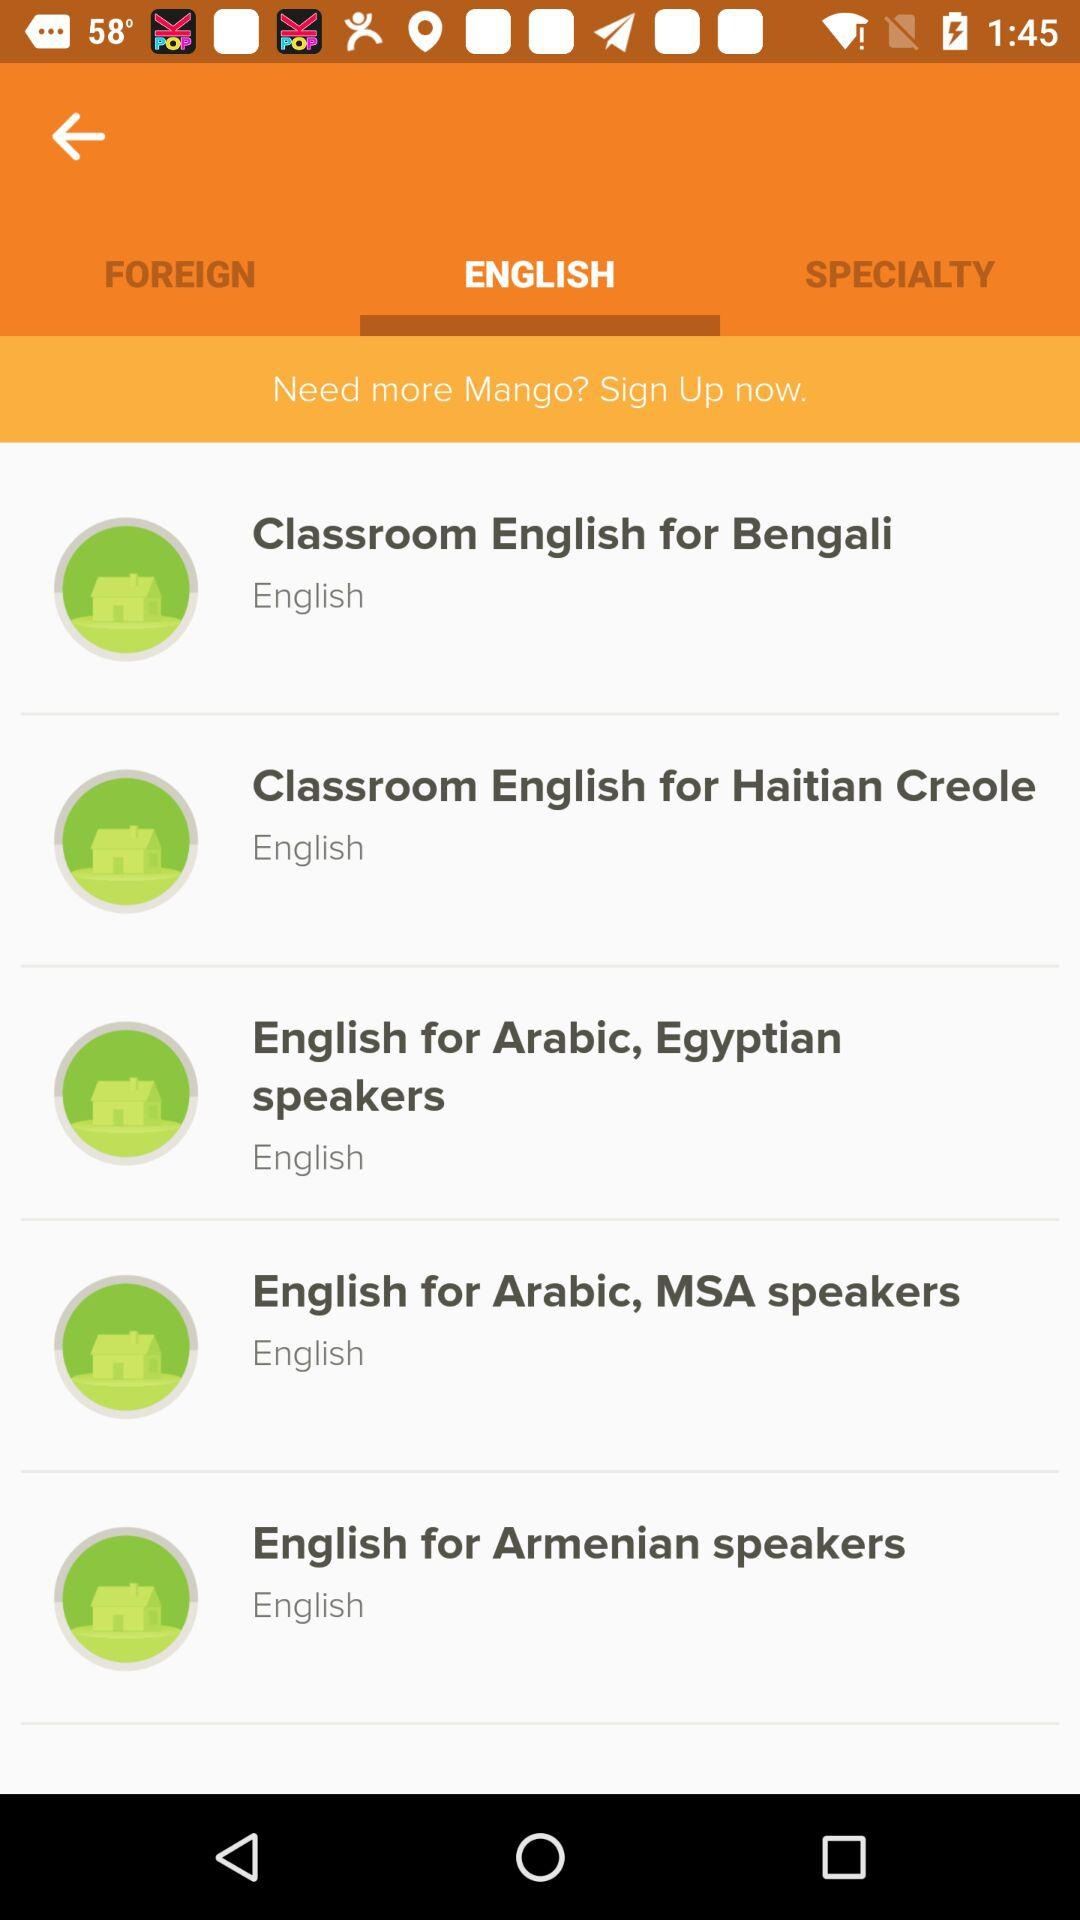In what language will the "English for Arabic, Egyptian speakers" class be held? The class will be held in English. 